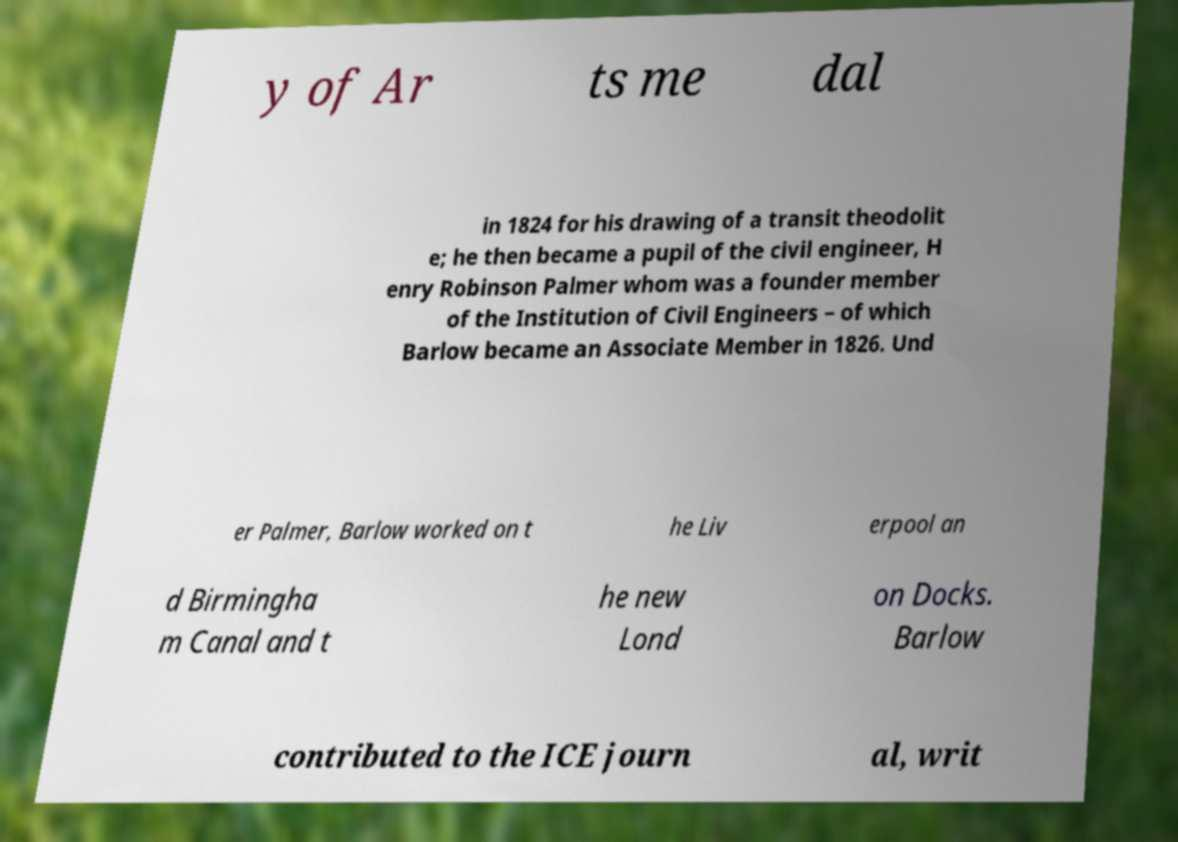There's text embedded in this image that I need extracted. Can you transcribe it verbatim? y of Ar ts me dal in 1824 for his drawing of a transit theodolit e; he then became a pupil of the civil engineer, H enry Robinson Palmer whom was a founder member of the Institution of Civil Engineers – of which Barlow became an Associate Member in 1826. Und er Palmer, Barlow worked on t he Liv erpool an d Birmingha m Canal and t he new Lond on Docks. Barlow contributed to the ICE journ al, writ 